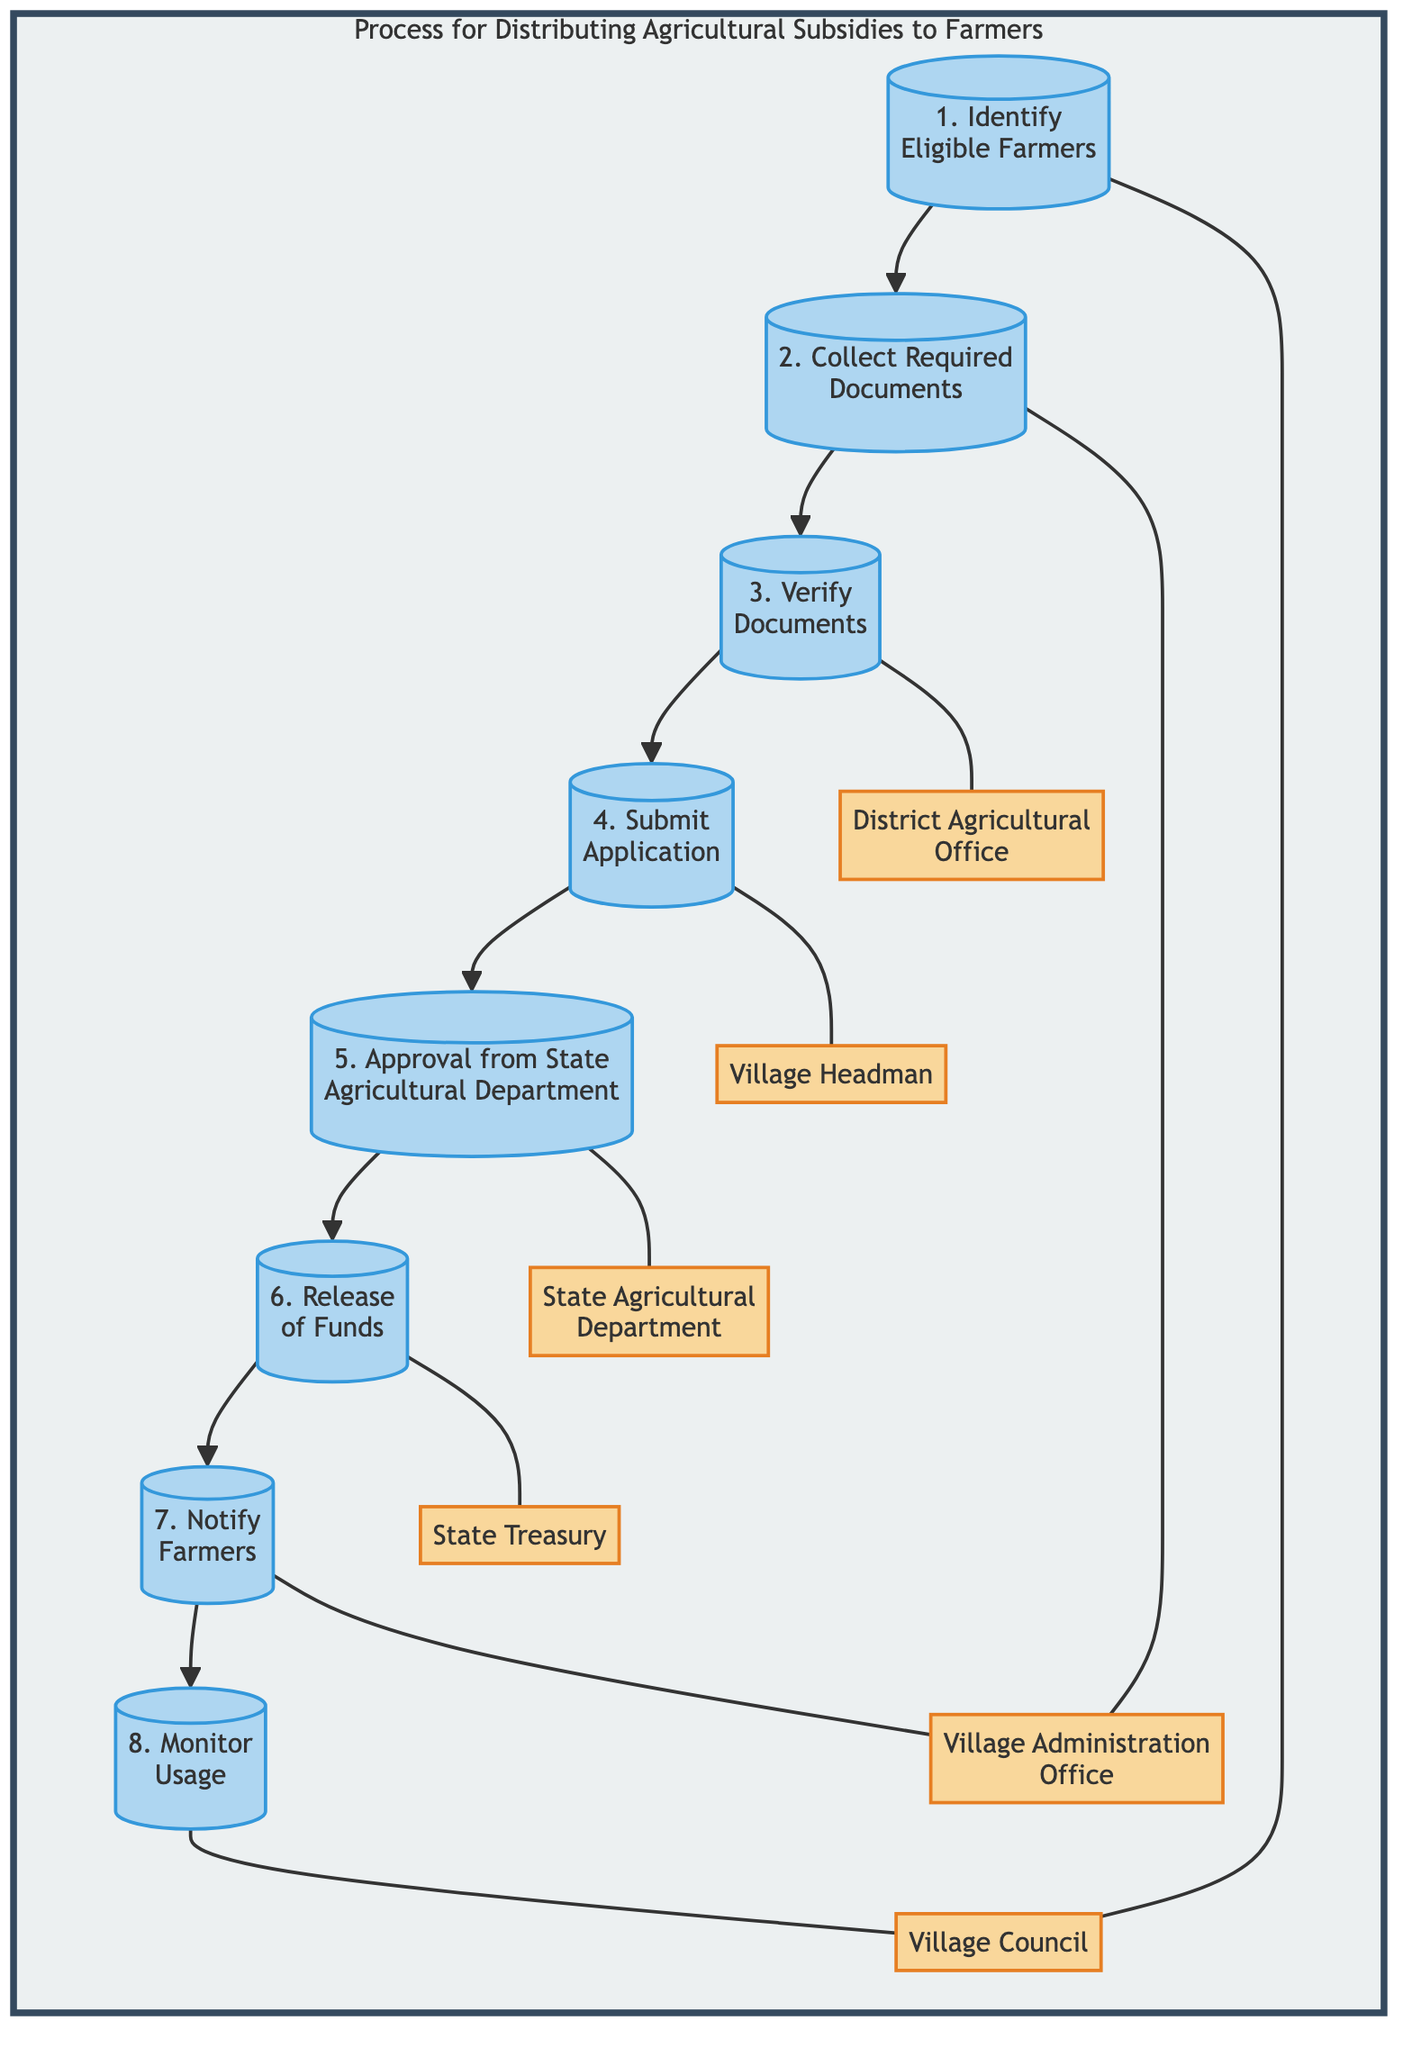What is the first step in the process? The diagram lists the first step as "Identify Eligible Farmers." This is obtained from the first step node in the flow chart.
Answer: Identify Eligible Farmers Who collects the required documents? The diagram specifies that the "Village Administration Office" is responsible for collecting the required documents. This can be found in the corresponding step node linked to this entity.
Answer: Village Administration Office How many steps are there in total? By counting the steps outlined in the diagram, we see there are a total of 8 steps in the process for distributing agricultural subsidies to farmers.
Answer: 8 What is the role of the Village Headman in this process? The Village Headman submits the verified documents and application form to the state agricultural department. This information is indicated in the flow from step 4.
Answer: Submit Application Which entity is responsible for verifying documents? The diagram indicates that the "District Agricultural Office" is in charge of verifying the authenticity of the documents collected in the previous step. This is derived from the flow connecting that step to the responsible entity.
Answer: District Agricultural Office What occurs after the approval from the State Agricultural Department? The step immediately following approval is the "Release of Funds," which indicates that the subsidies are transferred to farmers' bank accounts. This is a direct progression in the flow.
Answer: Release of Funds Which step involves notifying farmers? The diagram reveals that notifying farmers occurs in step 7, managed by the Village Administration Office, based on the connections between the steps and the entities involved.
Answer: Notify Farmers What happens to the subsidies after they are released? According to the last step, the usage of these funds is monitored to ensure they are used for intended agricultural activities, as specified in the last step of the process.
Answer: Monitor Usage 